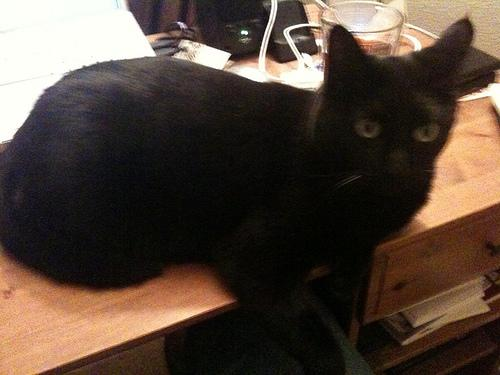What emotion does the cat appear to be expressing? Please explain your reasoning. surprise. The cat's eyes are open extra wide. 